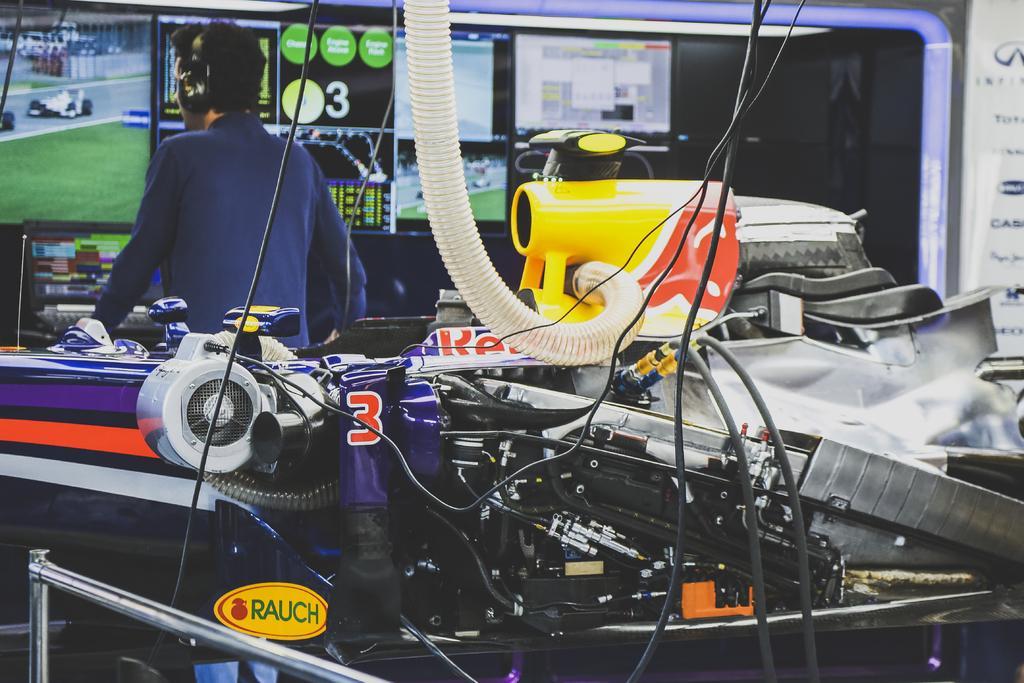Could you give a brief overview of what you see in this image? In this picture we can see a vehicle, in the background we can find few digital screens and a man, he wore headphones. 